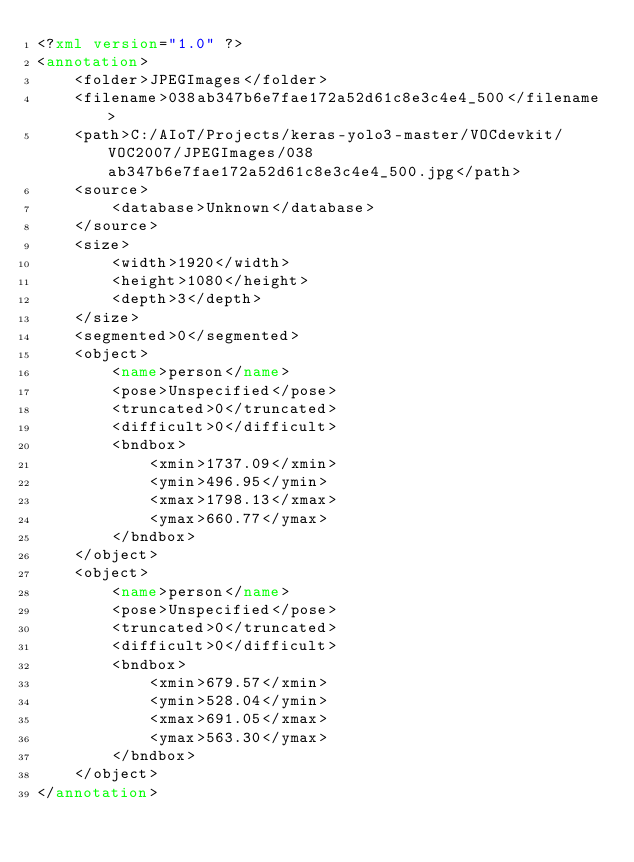<code> <loc_0><loc_0><loc_500><loc_500><_XML_><?xml version="1.0" ?>
<annotation>
	<folder>JPEGImages</folder>
	<filename>038ab347b6e7fae172a52d61c8e3c4e4_500</filename>
	<path>C:/AIoT/Projects/keras-yolo3-master/VOCdevkit/VOC2007/JPEGImages/038ab347b6e7fae172a52d61c8e3c4e4_500.jpg</path>
	<source>
		<database>Unknown</database>
	</source>
	<size>
		<width>1920</width>
		<height>1080</height>
		<depth>3</depth>
	</size>
	<segmented>0</segmented>
	<object>
		<name>person</name>
		<pose>Unspecified</pose>
		<truncated>0</truncated>
		<difficult>0</difficult>
		<bndbox>
			<xmin>1737.09</xmin>
			<ymin>496.95</ymin>
			<xmax>1798.13</xmax>
			<ymax>660.77</ymax>
		</bndbox>
	</object>
	<object>
		<name>person</name>
		<pose>Unspecified</pose>
		<truncated>0</truncated>
		<difficult>0</difficult>
		<bndbox>
			<xmin>679.57</xmin>
			<ymin>528.04</ymin>
			<xmax>691.05</xmax>
			<ymax>563.30</ymax>
		</bndbox>
	</object>
</annotation>
</code> 